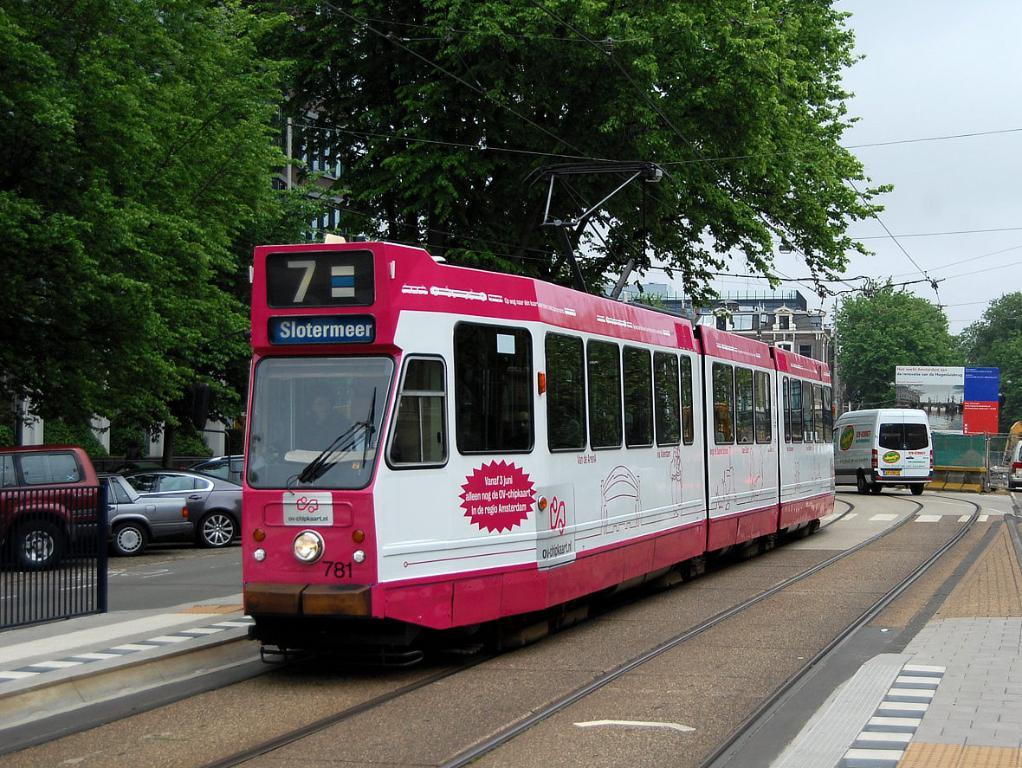<image>
Create a compact narrative representing the image presented. Red train going to Slotermeer going down the tracks. 